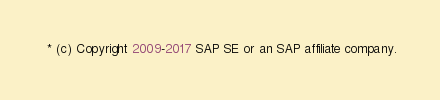Convert code to text. <code><loc_0><loc_0><loc_500><loc_500><_JavaScript_> * (c) Copyright 2009-2017 SAP SE or an SAP affiliate company.</code> 